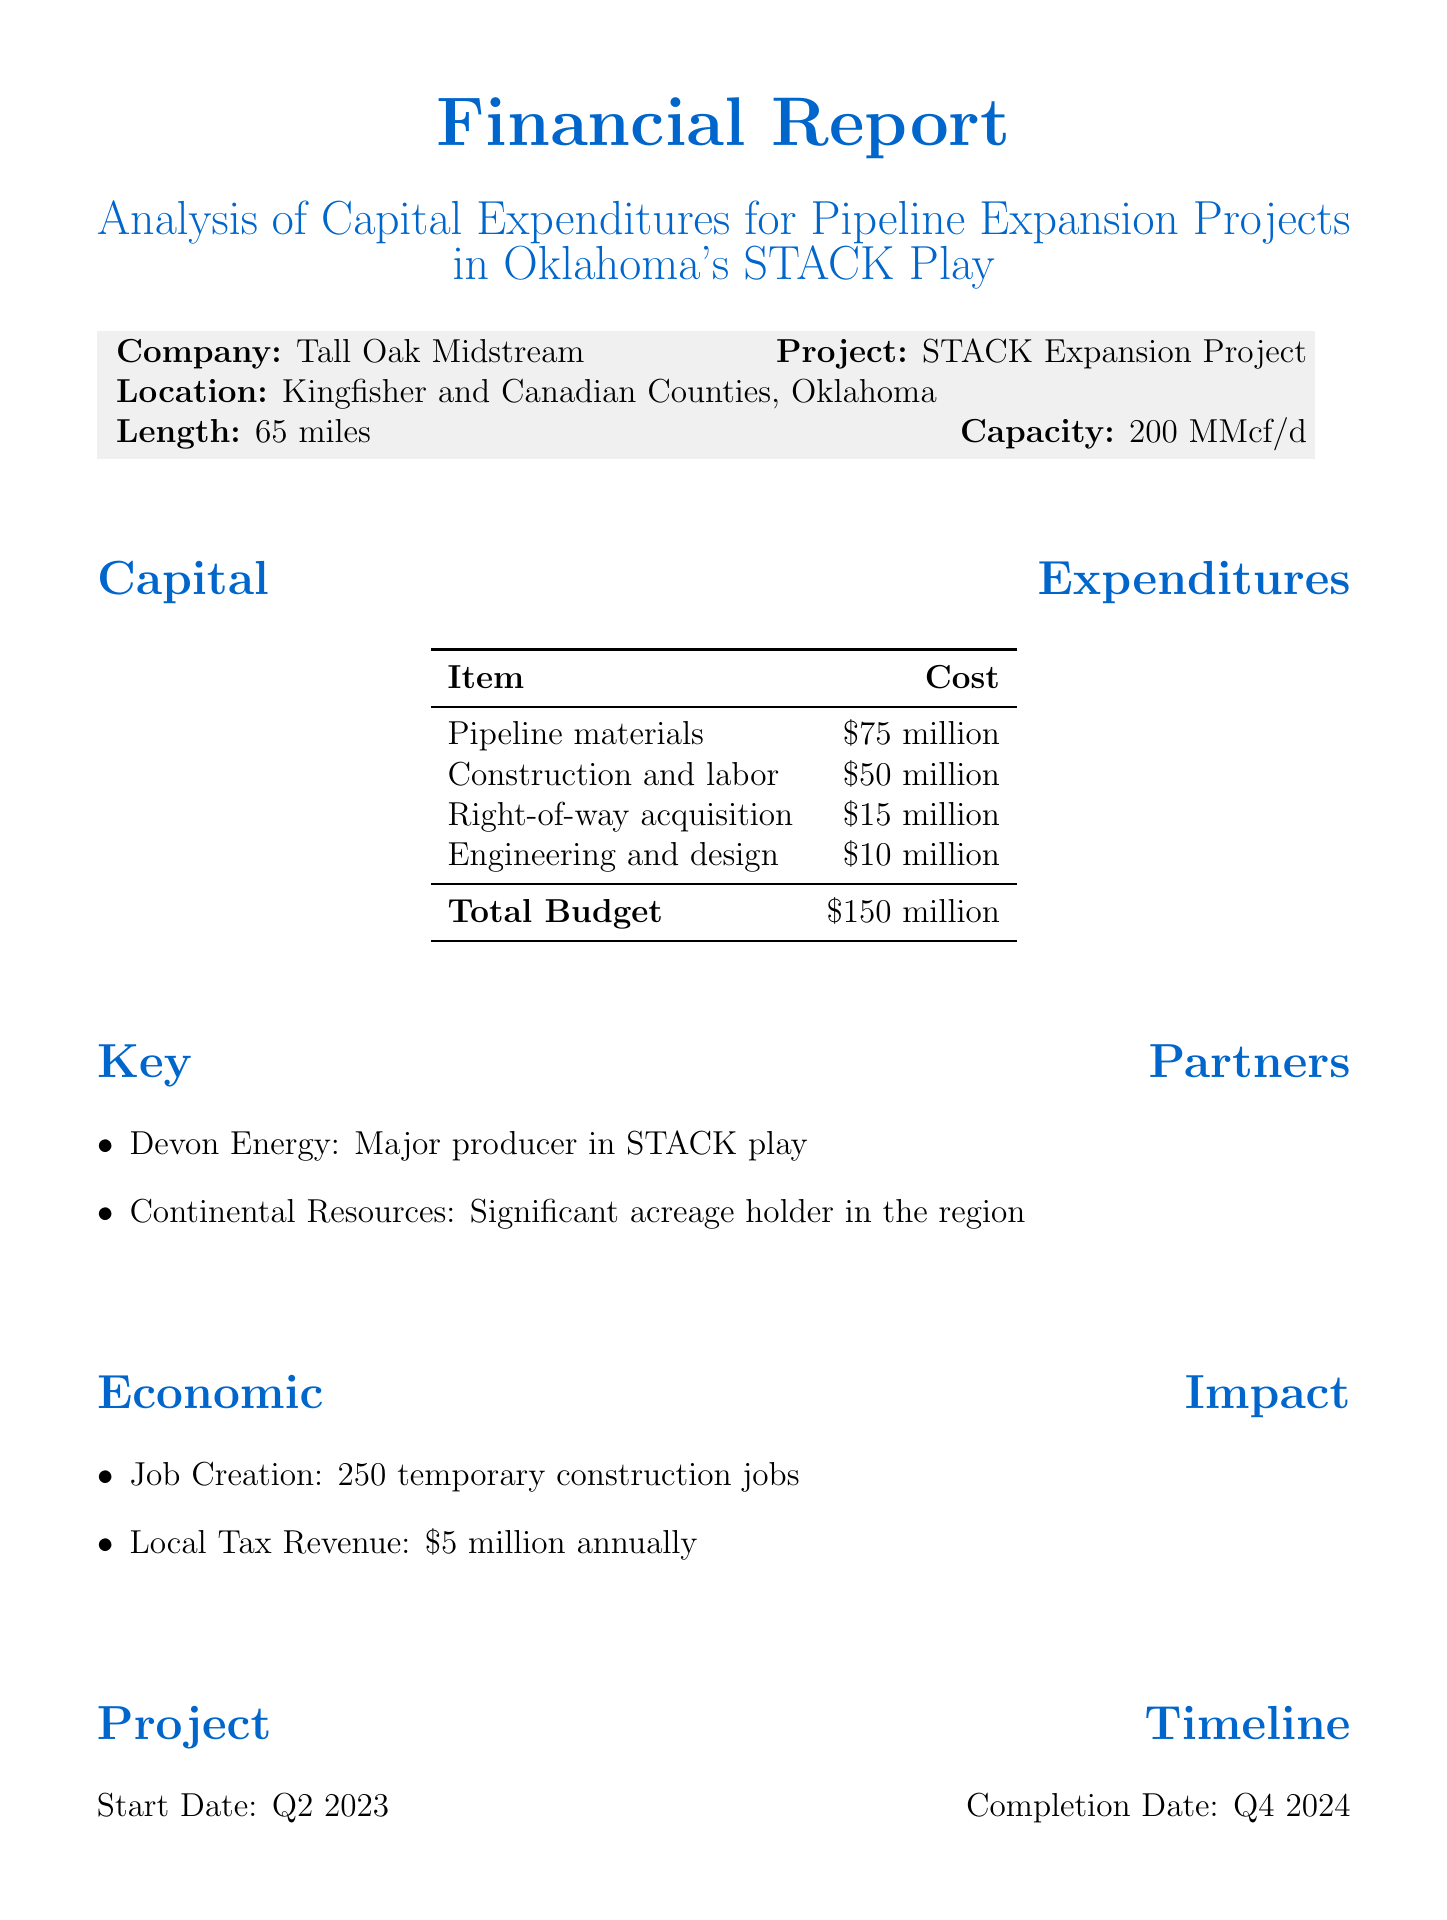What is the total budget for the project? The total budget is provided in the capital expenditures section of the document, which states it is $150 million.
Answer: $150 million What is the capacity of the STACK Expansion Project? The capacity is listed with the project details, which notes that it is 200 million cubic feet per day.
Answer: 200 million cubic feet per day How many temporary construction jobs will be created? The economic impact section specifies that the project will create 250 temporary construction jobs.
Answer: 250 temporary construction jobs What is the internal rate of return for the project? The financial projections section indicates that the internal rate of return is 15%.
Answer: 15% When is the completion date for the project? The project timeline section provides the completion date, which is Q4 2024.
Answer: Q4 2024 What mitigation measure is being implemented for sensitive areas? The environmental considerations section mentions that horizontal directional drilling is the mitigation measure for sensitive areas.
Answer: Horizontal directional drilling What is the role of Devon Energy in the project? The key partners section states that Devon Energy is a major producer in the STACK play.
Answer: Major producer in STACK play How much local tax revenue is expected annually? The economic impact section mentions that the expected local tax revenue is $5 million annually.
Answer: $5 million annually 